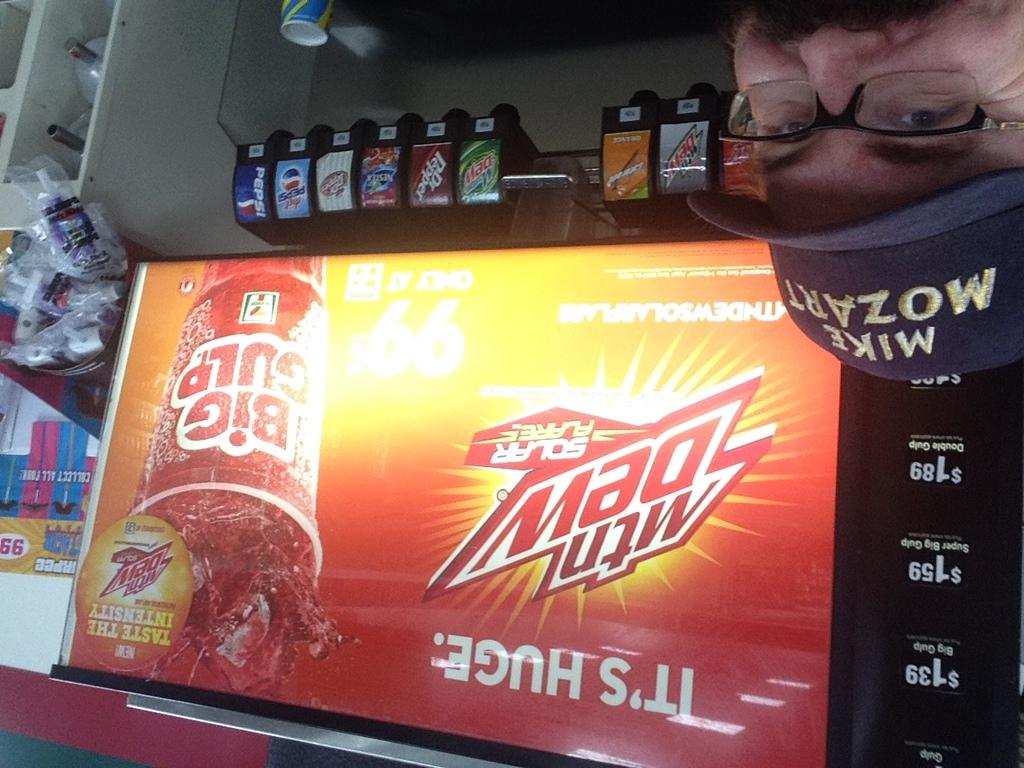<image>
Present a compact description of the photo's key features. A man posing next to a fountain drink dispenser with a large Mountain Dew advertisement. 